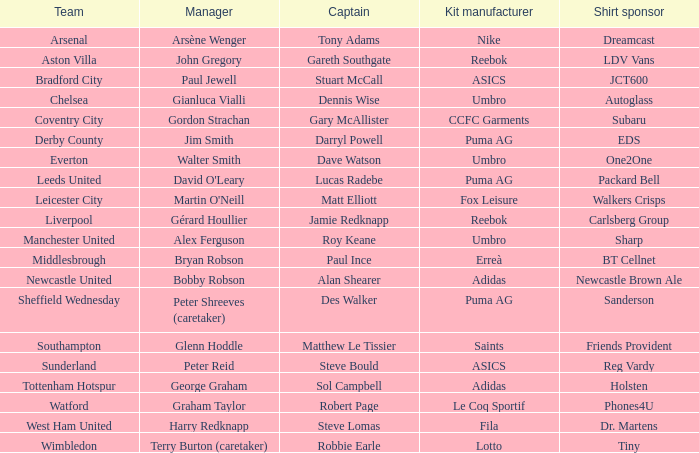Which team does David O'leary manage? Leeds United. 